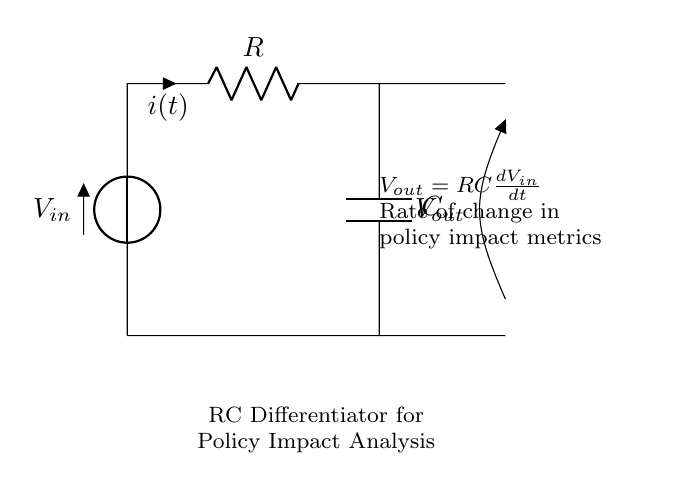What components are present in this circuit? The components are a resistor, a capacitor, and a voltage source. The resistor is labeled as R, the capacitor as C, and the voltage source as Vin.
Answer: Resistor, Capacitor, Voltage Source What does the output voltage depend on? The output voltage Vout depends on the rate of change of the input voltage Vin with respect to time, and is given by the equation Vout = RC(dVin/dt). This signifies that Vout is directly influenced by how quickly Vin changes.
Answer: Rate of change of input voltage What is the relationship between Vout and Vin? The relationship is defined by the equation Vout = RC(dVin/dt). This shows that the output voltage is a scaled derivative of the input voltage. The scaling factor is the product of the resistance and capacitance.
Answer: Vout = RC(dVin/dt) What is the role of the resistor in this circuit? The resistor limits the current through the circuit and works with the capacitor to determine the time constant. The time constant (RC) affects how quickly the circuit responds to changes in Vin.
Answer: Limits current and determines time constant What is indicated by the term "dVin/dt"? The term "dVin/dt" represents the derivative of the input voltage, which indicates the rate of change of Vin over time. It is crucial for analyzing dynamic changes in policy impact metrics as it reveals how rapidly these metrics fluctuate.
Answer: Rate of change of input voltage What happens to Vout if Vin remains constant? If Vin remains constant, then dVin/dt equals zero. As a result, Vout will also be zero since the output voltage is directly proportional to the rate of change of the input voltage.
Answer: Vout will be zero How does the circuit act as a differentiator? The circuit acts as a differentiator because it produces an output voltage that corresponds to the rate of change of the input voltage. This characteristic allows it to highlight rapid changes in the applied voltage, making it useful for analyzing dynamic metrics.
Answer: It highlights the rate of change of input voltage 